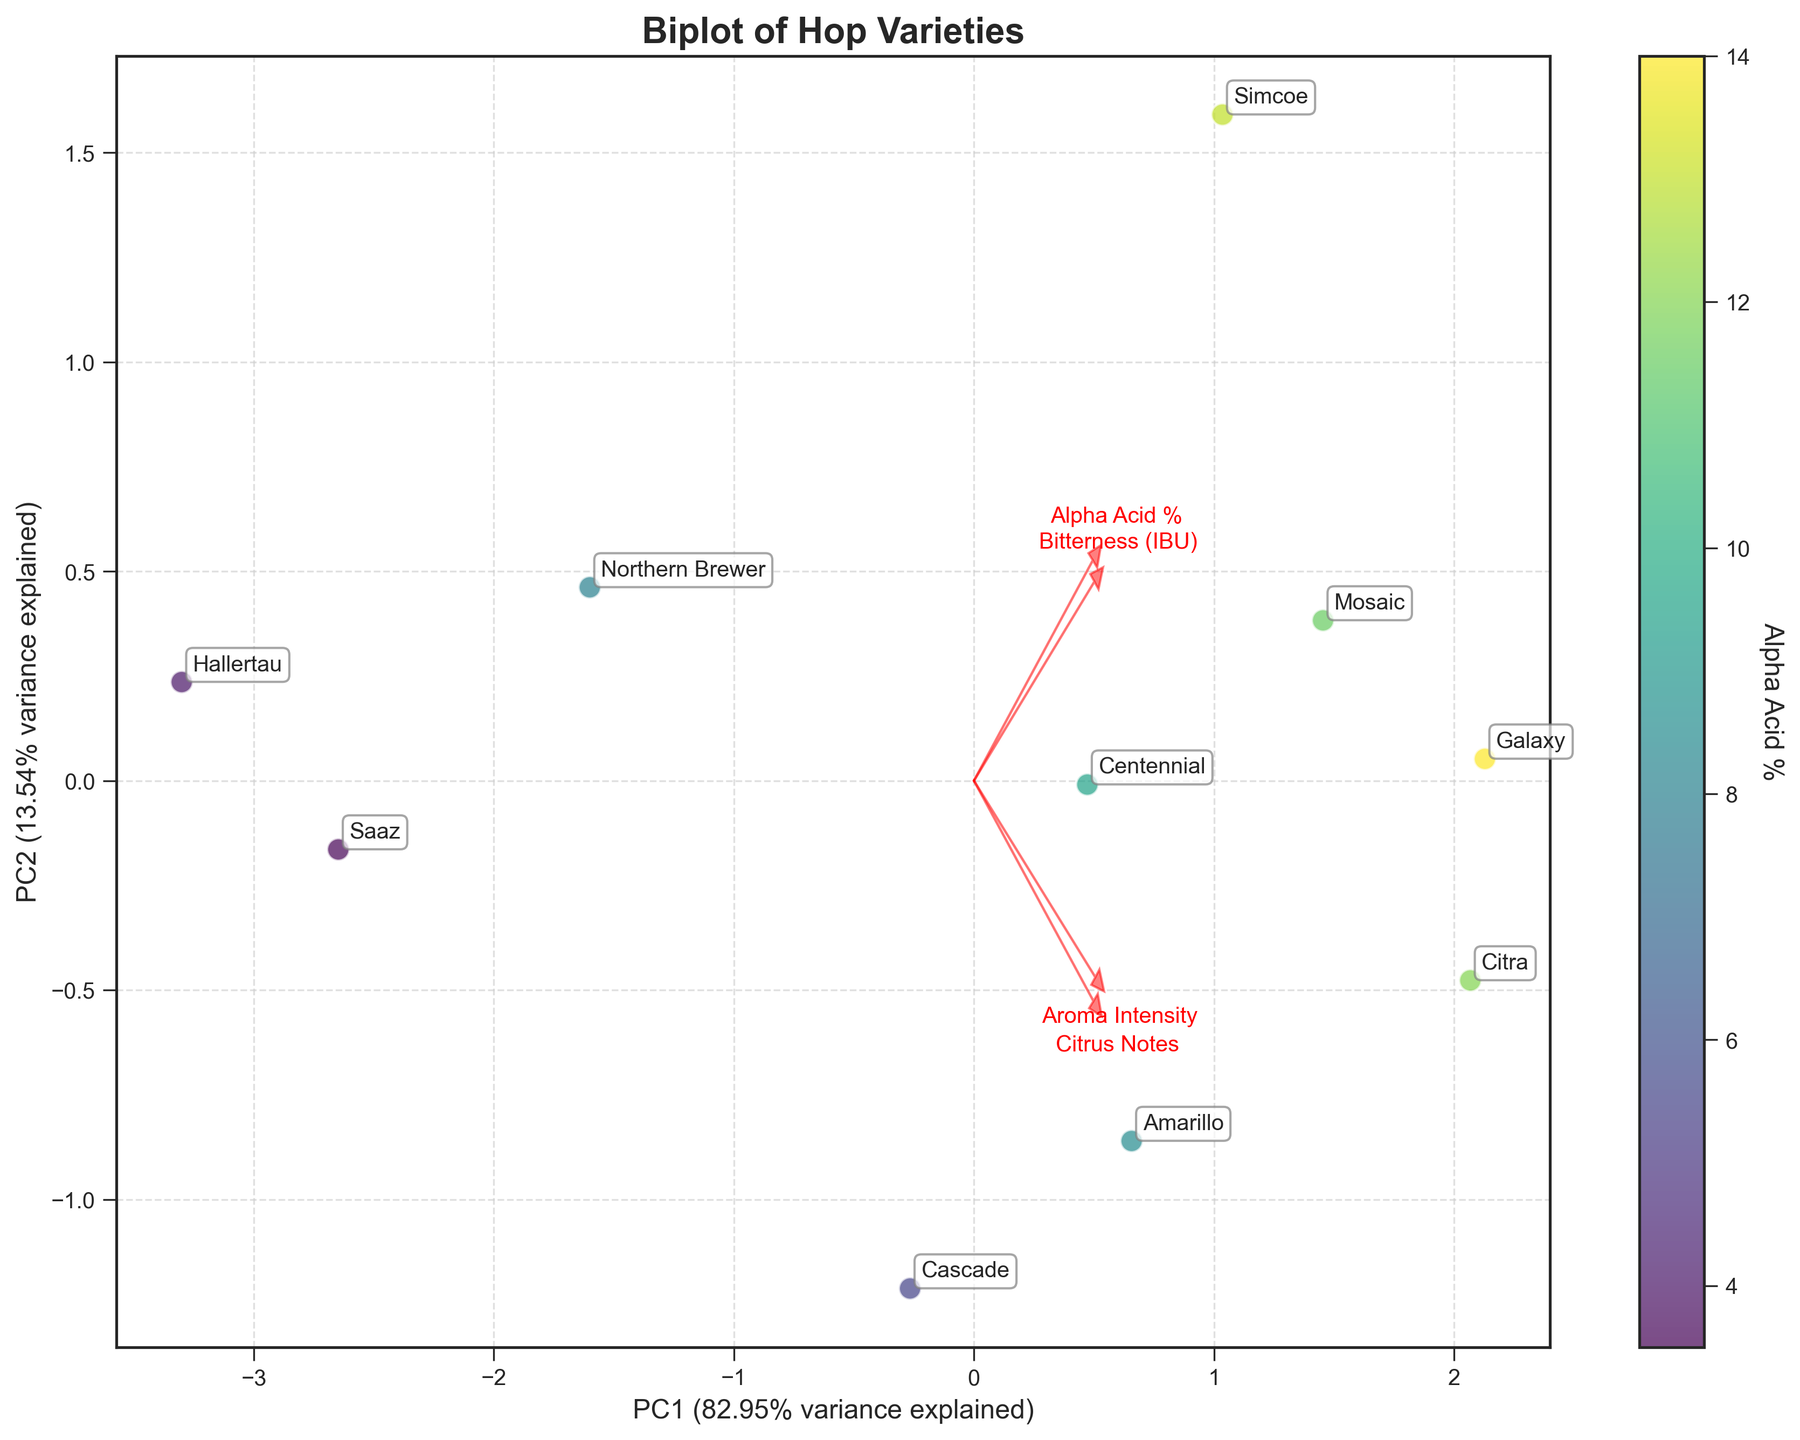What is the title of the figure? The title of the figure is typically displayed at the top center of the plot. Here, it is clearly marked as "Biplot of Hop Varieties".
Answer: Biplot of Hop Varieties How many hop varieties are displayed in the figure? Counting the number of labels associated with each data point will give the number of hop varieties displayed. There are 10 labels in the figure representing 10 different hop varieties.
Answer: 10 Which hop variety has the highest Alpha Acid % according to the color bar? The color bar indicates Alpha Acid %, with lighter colors representing higher values. The hop variety labeled "Galaxy" has the lightest color, indicating the highest Alpha Acid % of 14.0.
Answer: Galaxy Where does the feature "Bitterness (IBU)" vector point? By observing the direction and position of the vector labeled "Bitterness (IBU)", it points outwards from the origin towards the right side, indicating that higher scores in PC1 are associated with higher bitterness.
Answer: Towards the right Which two hop varieties are closest to each other on the plot? Closest points can be identified by comparing the relative distances between all points. In this case, "Citra" and "Amarillo" are the closest to each other.
Answer: Citra and Amarillo What percentage of variance does the first principal component (PC1) explain? The x-axis label shows "PC1" followed by the percentage of variance it explains. The figure indicates it explains 59.67% of the variance.
Answer: 59.67% Which hop variety has both high aroma intensity and high citrus notes? From the position of data points and feature vectors, "Citra" is near the ends of both the "Aroma Intensity" and "Citrus Notes" vectors, indicating it has high values for both traits.
Answer: Citra How does the flavor profile of "Simcoe" compare to "Saaz" in terms of bitterness and citrus notes? Based on the PCA plot, "Simcoe" is higher in the dimension associated with "Bitterness (IBU)" and slightly above the baseline for "Citrus Notes" compared to "Saaz", which has the lowest values in both categories as indicated by its position.
Answer: Simcoe is higher in bitterness and citrus notes than Saaz Which features are most and least influential in separating the hop varieties? Looking at the length of the vectors, "Bitterness (IBU)" and "Aroma Intensity" appear to have the longest vectors, indicating they are most influential. "Hallertau" marker shows that the least influential feature appears to be "Citrus Notes" based on the shortest vector.
Answer: Most: Bitterness (IBU) and Aroma Intensity, Least: Citrus Notes How do "Northern Brewer" and "Centennial" compare in terms of Alpha Acid % and bitterness? From their positions and the color bar, "Centennial" has a slightly higher Alpha Acid % compared to "Northern Brewer". "Centennial" also has higher Bitterness (IBU) as it is further along the "Bitterness (IBU)" vector than "Northern Brewer".
Answer: Centennial has higher values for both 